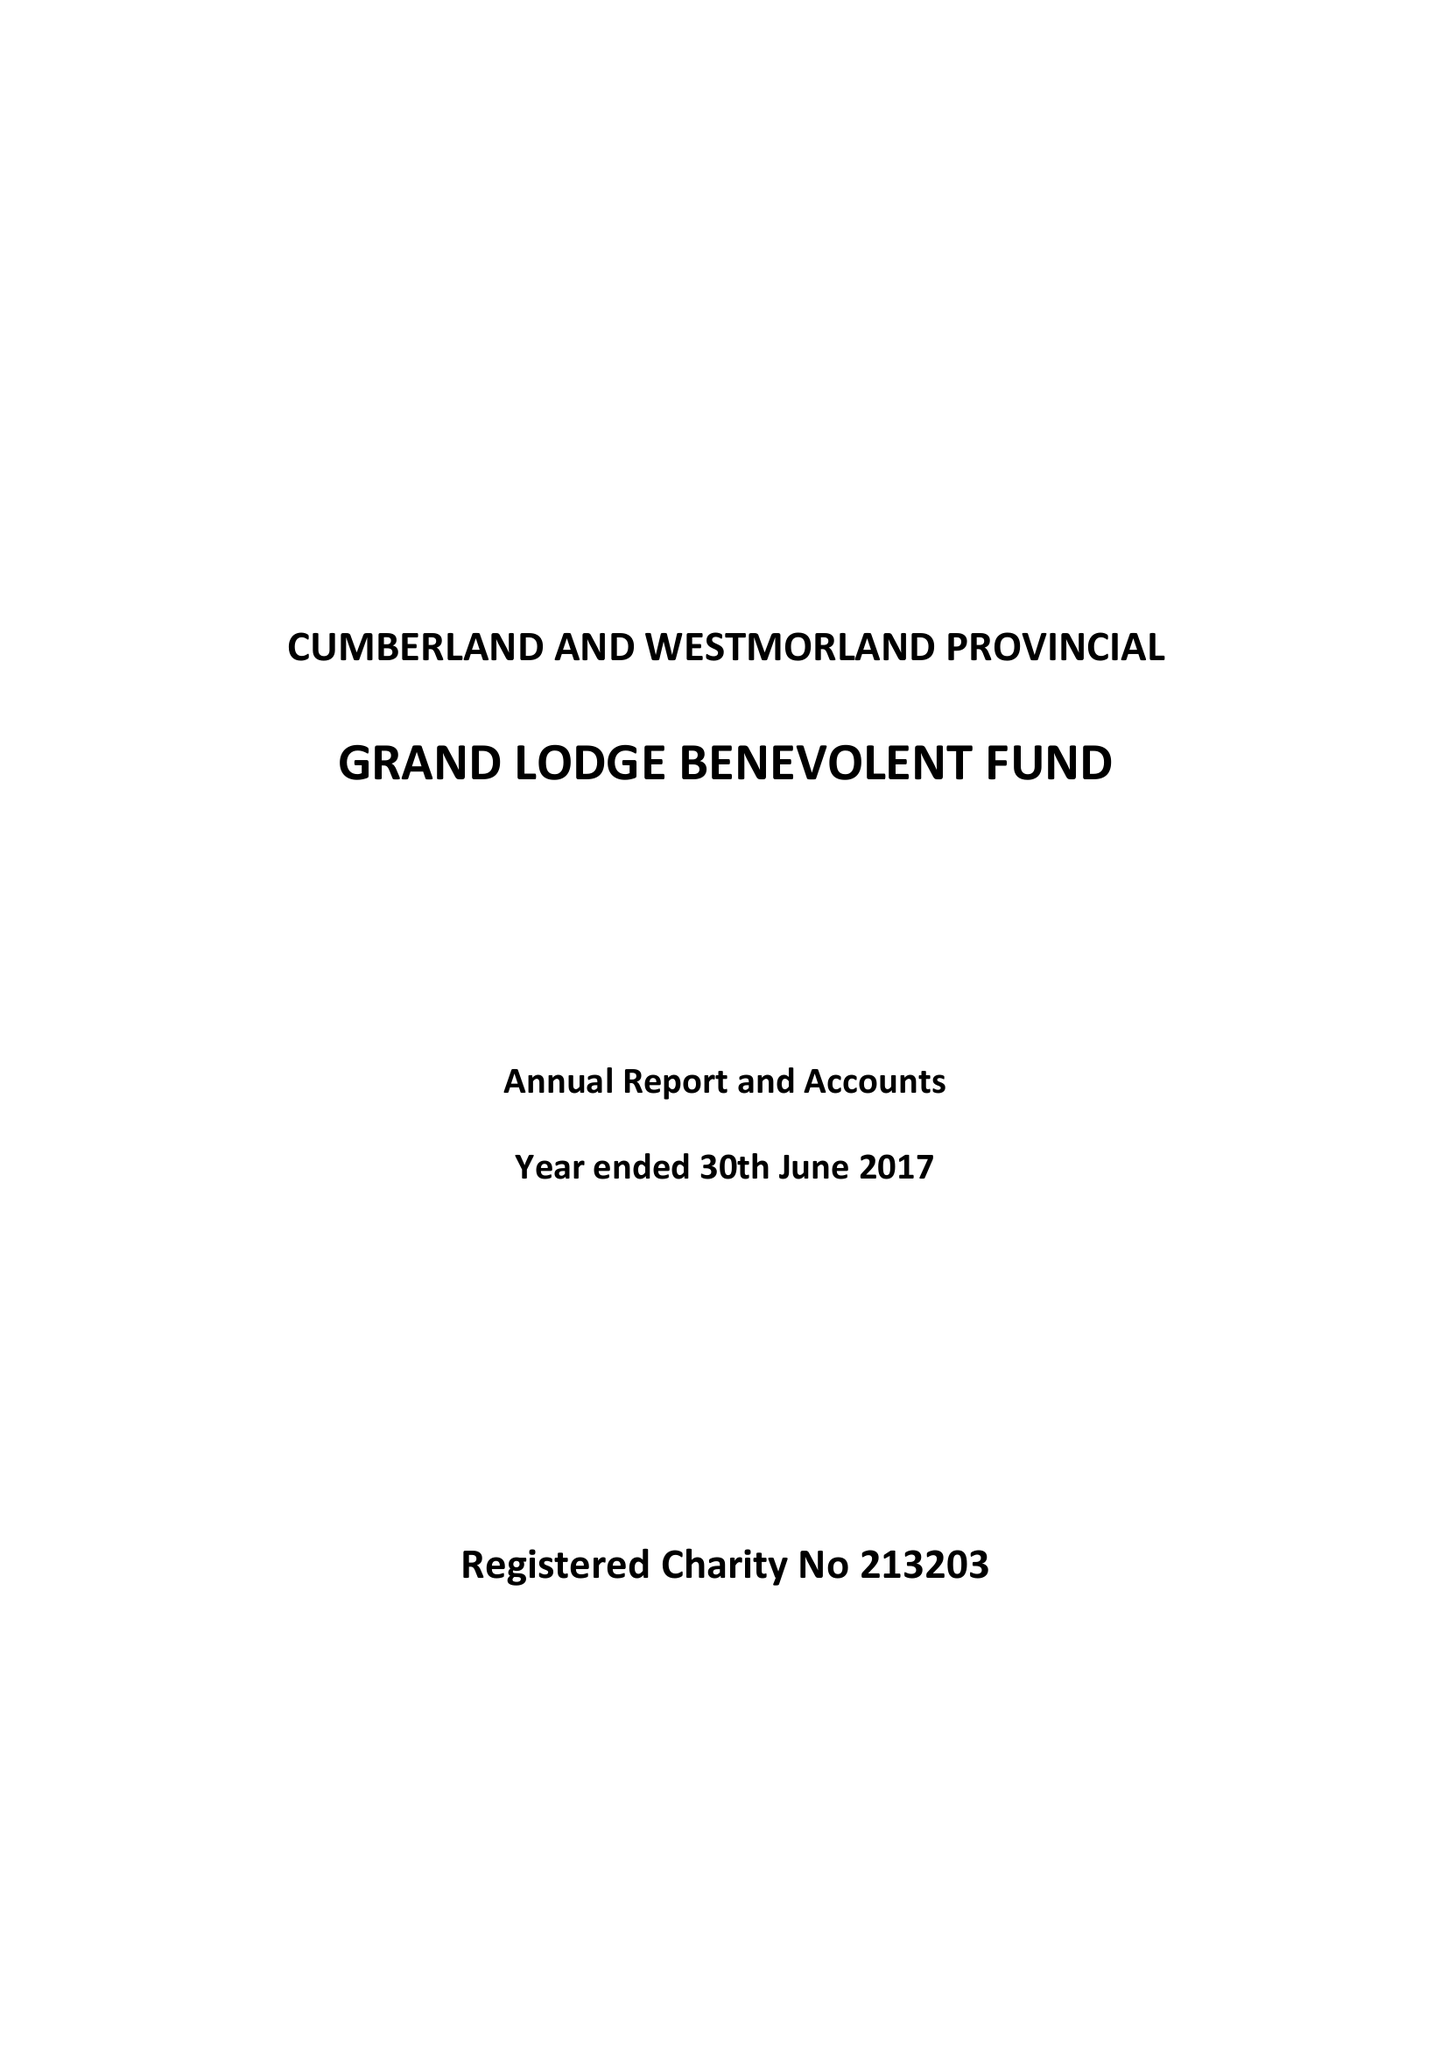What is the value for the address__street_line?
Answer the question using a single word or phrase. None 